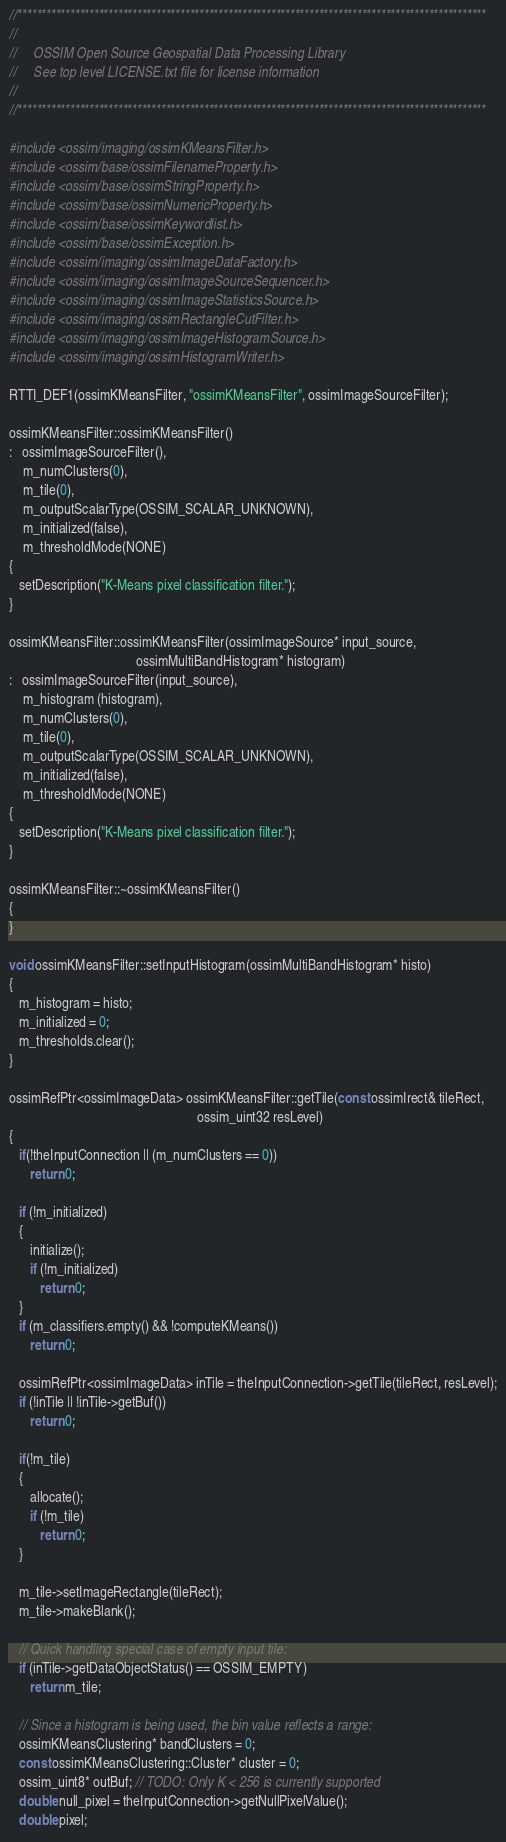Convert code to text. <code><loc_0><loc_0><loc_500><loc_500><_C++_>//**************************************************************************************************
//
//     OSSIM Open Source Geospatial Data Processing Library
//     See top level LICENSE.txt file for license information
//
//**************************************************************************************************

#include <ossim/imaging/ossimKMeansFilter.h>
#include <ossim/base/ossimFilenameProperty.h>
#include <ossim/base/ossimStringProperty.h>
#include <ossim/base/ossimNumericProperty.h>
#include <ossim/base/ossimKeywordlist.h>
#include <ossim/base/ossimException.h>
#include <ossim/imaging/ossimImageDataFactory.h>
#include <ossim/imaging/ossimImageSourceSequencer.h>
#include <ossim/imaging/ossimImageStatisticsSource.h>
#include <ossim/imaging/ossimRectangleCutFilter.h>
#include <ossim/imaging/ossimImageHistogramSource.h>
#include <ossim/imaging/ossimHistogramWriter.h>

RTTI_DEF1(ossimKMeansFilter, "ossimKMeansFilter", ossimImageSourceFilter);

ossimKMeansFilter::ossimKMeansFilter()
:   ossimImageSourceFilter(),
    m_numClusters(0),
    m_tile(0),
    m_outputScalarType(OSSIM_SCALAR_UNKNOWN),
    m_initialized(false),
    m_thresholdMode(NONE)
{
   setDescription("K-Means pixel classification filter.");
}

ossimKMeansFilter::ossimKMeansFilter(ossimImageSource* input_source,
                                     ossimMultiBandHistogram* histogram)
:   ossimImageSourceFilter(input_source),
    m_histogram (histogram),
    m_numClusters(0),
    m_tile(0),
    m_outputScalarType(OSSIM_SCALAR_UNKNOWN),
    m_initialized(false),
    m_thresholdMode(NONE)
{
   setDescription("K-Means pixel classification filter.");
}

ossimKMeansFilter::~ossimKMeansFilter()
{
}

void ossimKMeansFilter::setInputHistogram(ossimMultiBandHistogram* histo)
{
   m_histogram = histo;
   m_initialized = 0;
   m_thresholds.clear();
}

ossimRefPtr<ossimImageData> ossimKMeansFilter::getTile(const ossimIrect& tileRect,
                                                       ossim_uint32 resLevel)
{
   if(!theInputConnection || (m_numClusters == 0))
      return 0;

   if (!m_initialized)
   {
      initialize();
      if (!m_initialized)
         return 0;
   }
   if (m_classifiers.empty() && !computeKMeans())
      return 0;

   ossimRefPtr<ossimImageData> inTile = theInputConnection->getTile(tileRect, resLevel);
   if (!inTile || !inTile->getBuf())
      return 0;

   if(!m_tile)
   {
      allocate();
      if (!m_tile)
         return 0;
   }

   m_tile->setImageRectangle(tileRect);
   m_tile->makeBlank();

   // Quick handling special case of empty input tile:
   if (inTile->getDataObjectStatus() == OSSIM_EMPTY)
      return m_tile;

   // Since a histogram is being used, the bin value reflects a range:
   ossimKMeansClustering* bandClusters = 0;
   const ossimKMeansClustering::Cluster* cluster = 0;
   ossim_uint8* outBuf; // TODO: Only K < 256 is currently supported
   double null_pixel = theInputConnection->getNullPixelValue();
   double pixel;</code> 